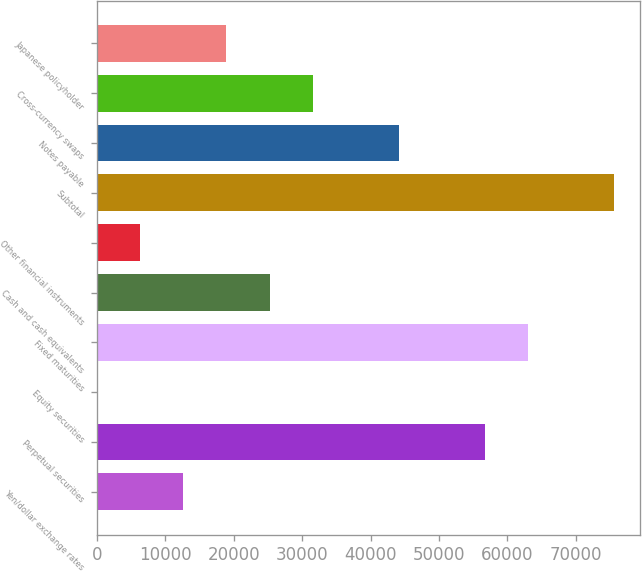<chart> <loc_0><loc_0><loc_500><loc_500><bar_chart><fcel>Yen/dollar exchange rates<fcel>Perpetual securities<fcel>Equity securities<fcel>Fixed maturities<fcel>Cash and cash equivalents<fcel>Other financial instruments<fcel>Subtotal<fcel>Notes payable<fcel>Cross-currency swaps<fcel>Japanese policyholder<nl><fcel>12623.4<fcel>56728.3<fcel>22<fcel>63029<fcel>25224.8<fcel>6322.7<fcel>75630.4<fcel>44126.9<fcel>31525.5<fcel>18924.1<nl></chart> 